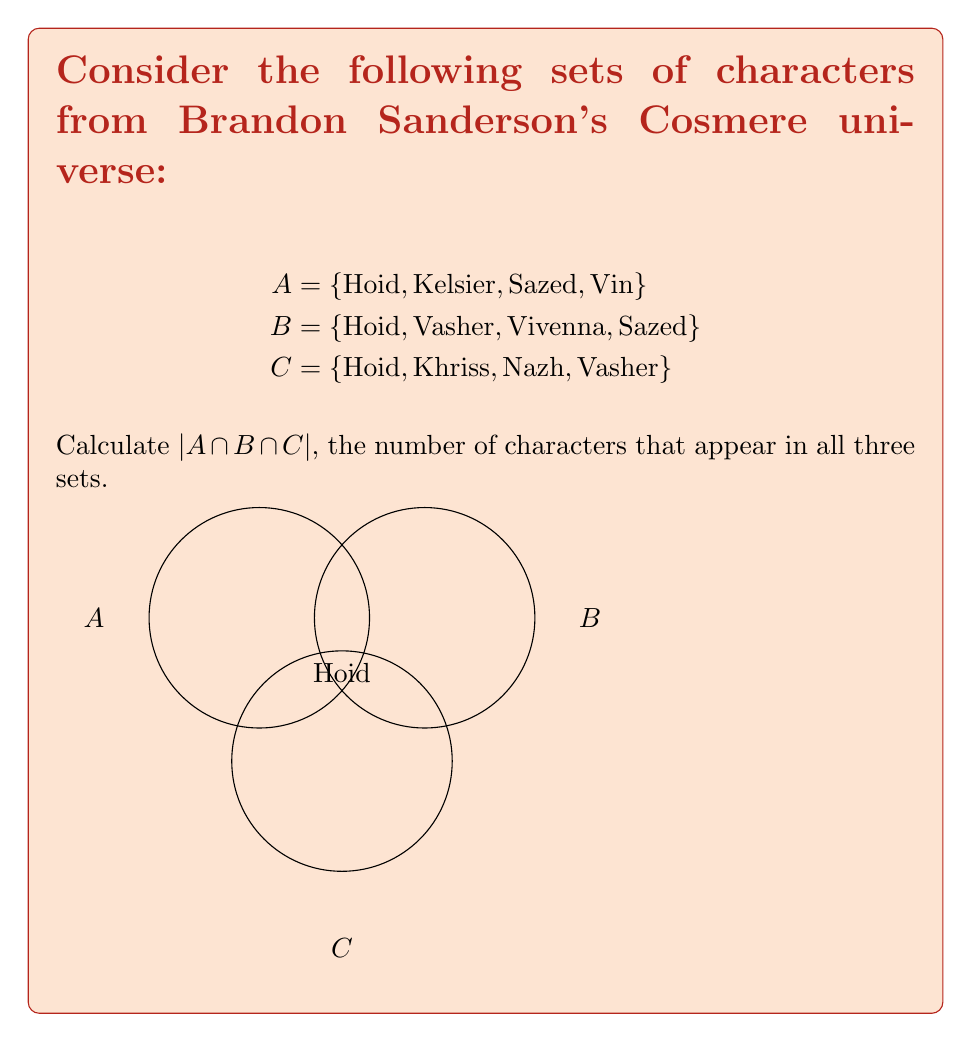Help me with this question. To solve this problem, we need to follow these steps:

1) First, let's identify the elements in each set:
   A = {Hoid, Kelsier, Sazed, Vin}
   B = {Hoid, Vasher, Vivenna, Sazed}
   C = {Hoid, Khriss, Nazh, Vasher}

2) Now, we need to find the intersection of all three sets. This means we're looking for characters that appear in A AND B AND C.

3) Let's start with A ∩ B:
   A ∩ B = {Hoid, Sazed}

4) Now, we need to intersect this result with C:
   (A ∩ B) ∩ C = {Hoid}

5) We can see that Hoid is the only character that appears in all three sets.

6) Therefore, $|A \cap B \cap C| = 1$

This result aligns with the Cosmere lore, as Hoid (also known as Wit) is a worldhopper who appears in multiple Sanderson series across the Cosmere.
Answer: $|A \cap B \cap C| = 1$ 